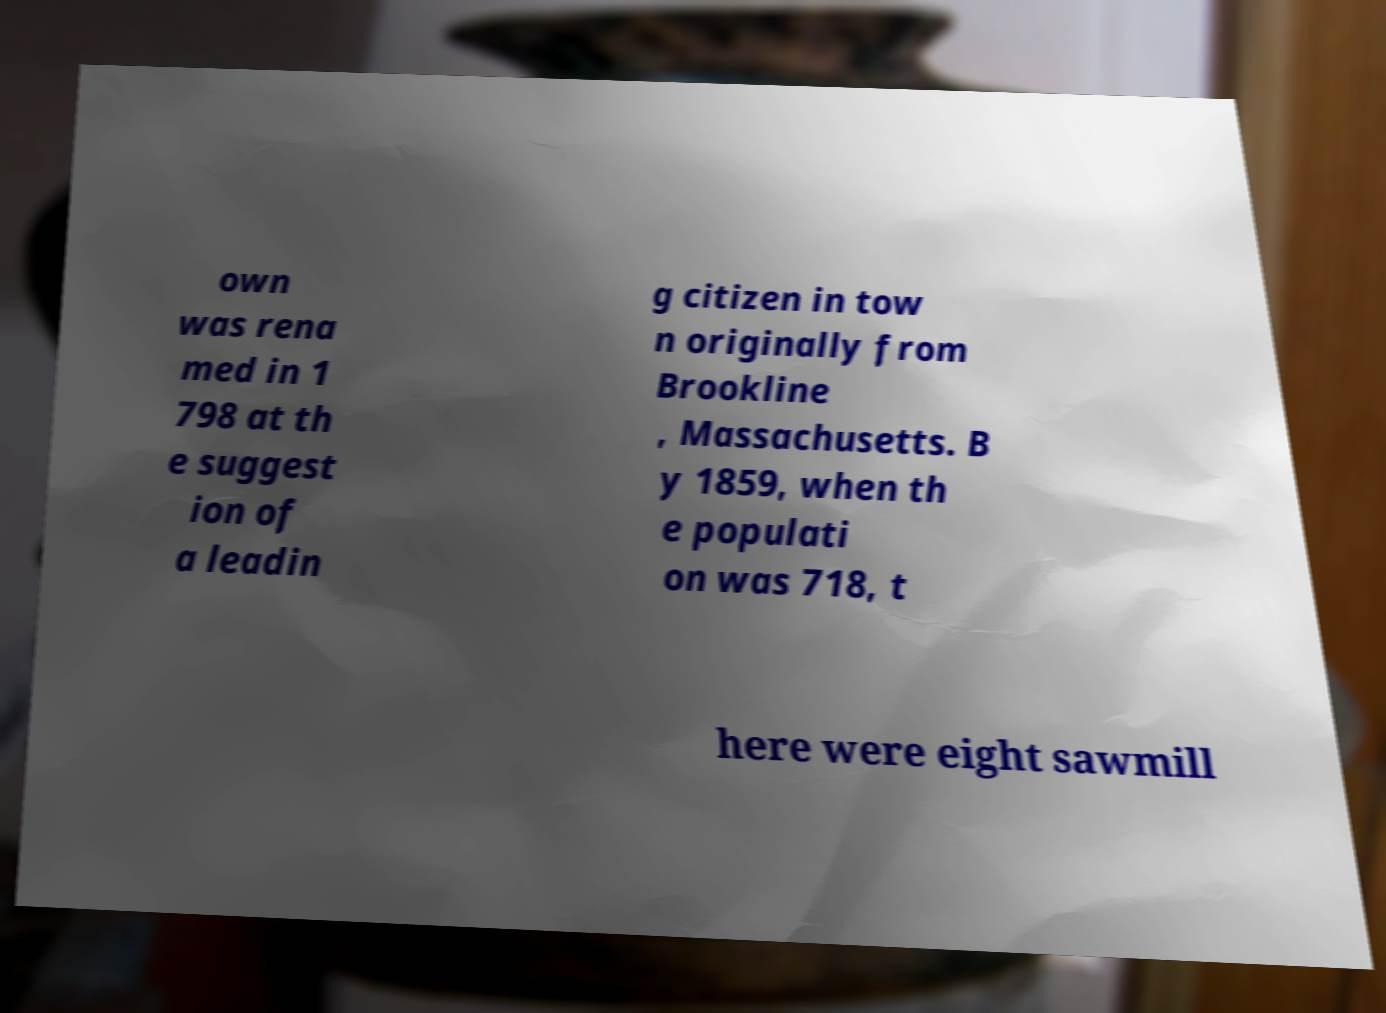Can you read and provide the text displayed in the image?This photo seems to have some interesting text. Can you extract and type it out for me? own was rena med in 1 798 at th e suggest ion of a leadin g citizen in tow n originally from Brookline , Massachusetts. B y 1859, when th e populati on was 718, t here were eight sawmill 